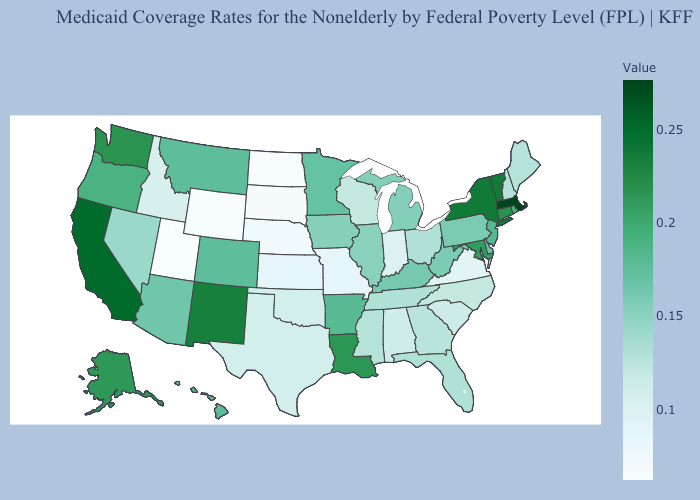Among the states that border New Mexico , which have the highest value?
Answer briefly. Colorado. Which states have the lowest value in the Northeast?
Give a very brief answer. Maine, New Hampshire. Which states have the lowest value in the South?
Quick response, please. Virginia. Among the states that border Virginia , does North Carolina have the highest value?
Answer briefly. No. 